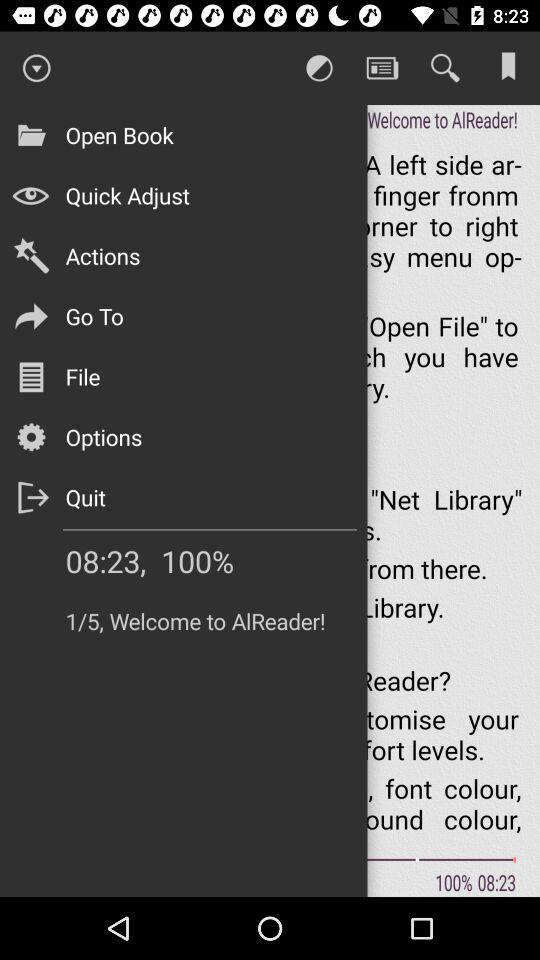What percentage has been displayed? The percentage that has been displayed is 100. 